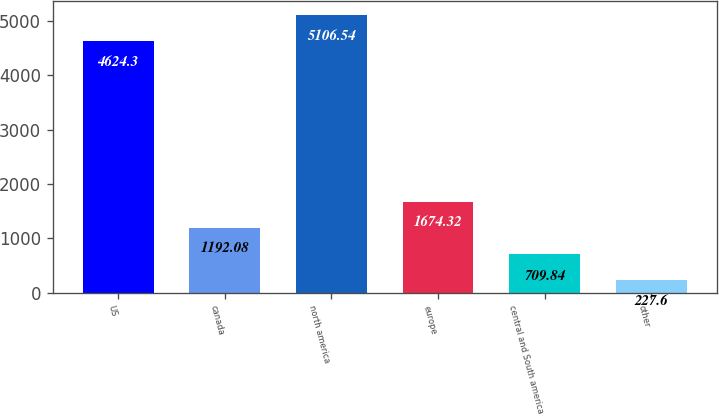Convert chart to OTSL. <chart><loc_0><loc_0><loc_500><loc_500><bar_chart><fcel>US<fcel>canada<fcel>north america<fcel>europe<fcel>central and South america<fcel>other<nl><fcel>4624.3<fcel>1192.08<fcel>5106.54<fcel>1674.32<fcel>709.84<fcel>227.6<nl></chart> 